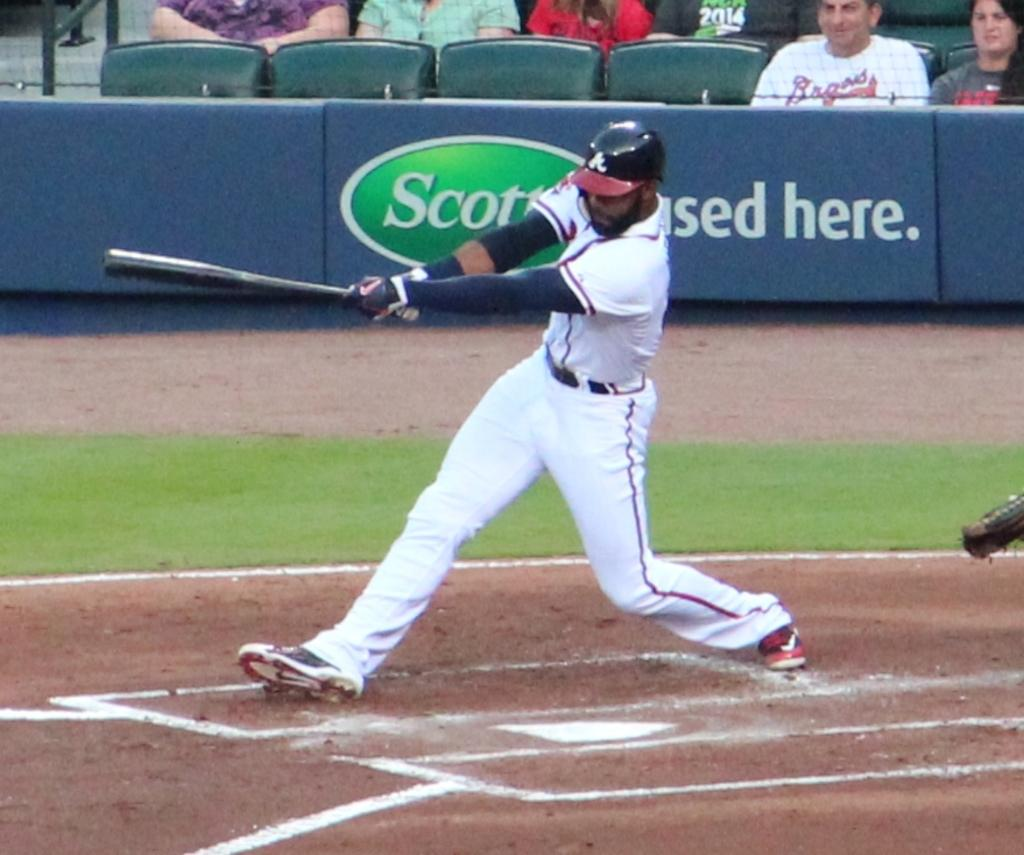<image>
Create a compact narrative representing the image presented. A baseball player is holding a bat in front of a sign for Scott. 